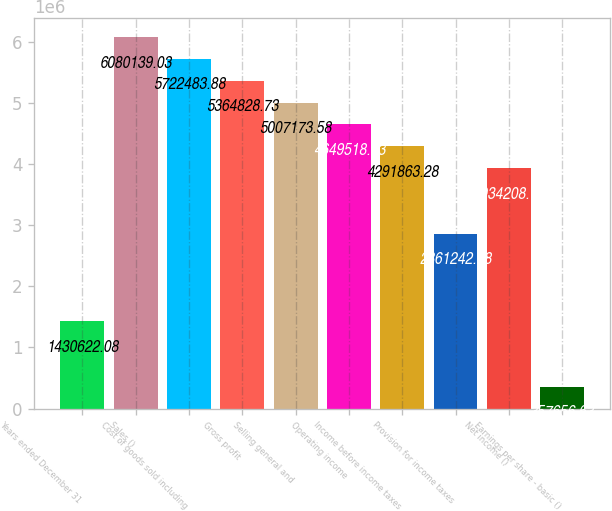Convert chart to OTSL. <chart><loc_0><loc_0><loc_500><loc_500><bar_chart><fcel>Years ended December 31<fcel>Sales ()<fcel>Cost of goods sold including<fcel>Gross profit<fcel>Selling general and<fcel>Operating income<fcel>Income before income taxes<fcel>Provision for income taxes<fcel>Net income ()<fcel>Earnings per share - basic ()<nl><fcel>1.43062e+06<fcel>6.08014e+06<fcel>5.72248e+06<fcel>5.36483e+06<fcel>5.00717e+06<fcel>4.64952e+06<fcel>4.29186e+06<fcel>2.86124e+06<fcel>3.93421e+06<fcel>357657<nl></chart> 